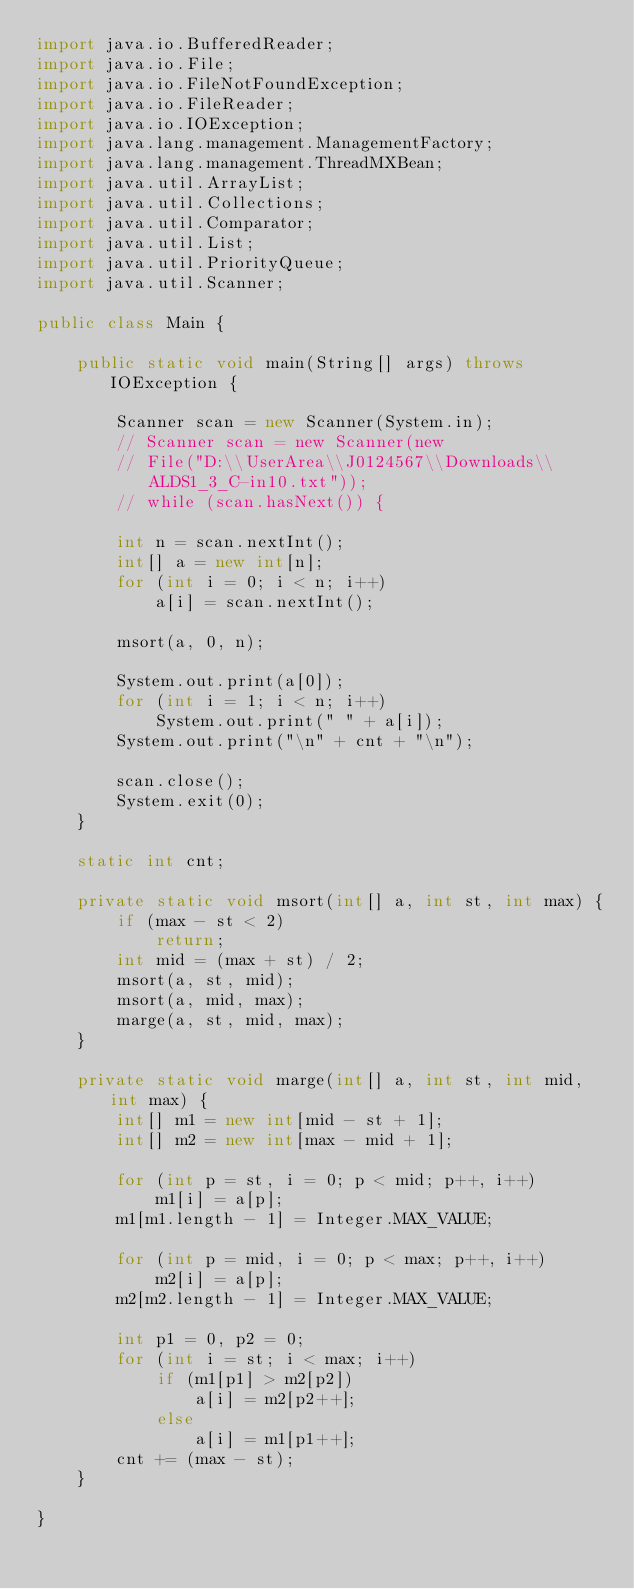Convert code to text. <code><loc_0><loc_0><loc_500><loc_500><_Java_>import java.io.BufferedReader;
import java.io.File;
import java.io.FileNotFoundException;
import java.io.FileReader;
import java.io.IOException;
import java.lang.management.ManagementFactory;
import java.lang.management.ThreadMXBean;
import java.util.ArrayList;
import java.util.Collections;
import java.util.Comparator;
import java.util.List;
import java.util.PriorityQueue;
import java.util.Scanner;

public class Main {

	public static void main(String[] args) throws IOException {

		Scanner scan = new Scanner(System.in);
		// Scanner scan = new Scanner(new
		// File("D:\\UserArea\\J0124567\\Downloads\\ALDS1_3_C-in10.txt"));
		// while (scan.hasNext()) {

		int n = scan.nextInt();
		int[] a = new int[n];
		for (int i = 0; i < n; i++)
			a[i] = scan.nextInt();

		msort(a, 0, n);

		System.out.print(a[0]);
		for (int i = 1; i < n; i++)
			System.out.print(" " + a[i]);
		System.out.print("\n" + cnt + "\n");

		scan.close();
		System.exit(0);
	}

	static int cnt;

	private static void msort(int[] a, int st, int max) {
		if (max - st < 2)
			return;
		int mid = (max + st) / 2;
		msort(a, st, mid);
		msort(a, mid, max);
		marge(a, st, mid, max);
	}

	private static void marge(int[] a, int st, int mid, int max) {
		int[] m1 = new int[mid - st + 1];
		int[] m2 = new int[max - mid + 1];

		for (int p = st, i = 0; p < mid; p++, i++)
			m1[i] = a[p];
		m1[m1.length - 1] = Integer.MAX_VALUE;

		for (int p = mid, i = 0; p < max; p++, i++)
			m2[i] = a[p];
		m2[m2.length - 1] = Integer.MAX_VALUE;

		int p1 = 0, p2 = 0;
		for (int i = st; i < max; i++)
			if (m1[p1] > m2[p2])
				a[i] = m2[p2++];
			else
				a[i] = m1[p1++];
		cnt += (max - st);
	}

}</code> 